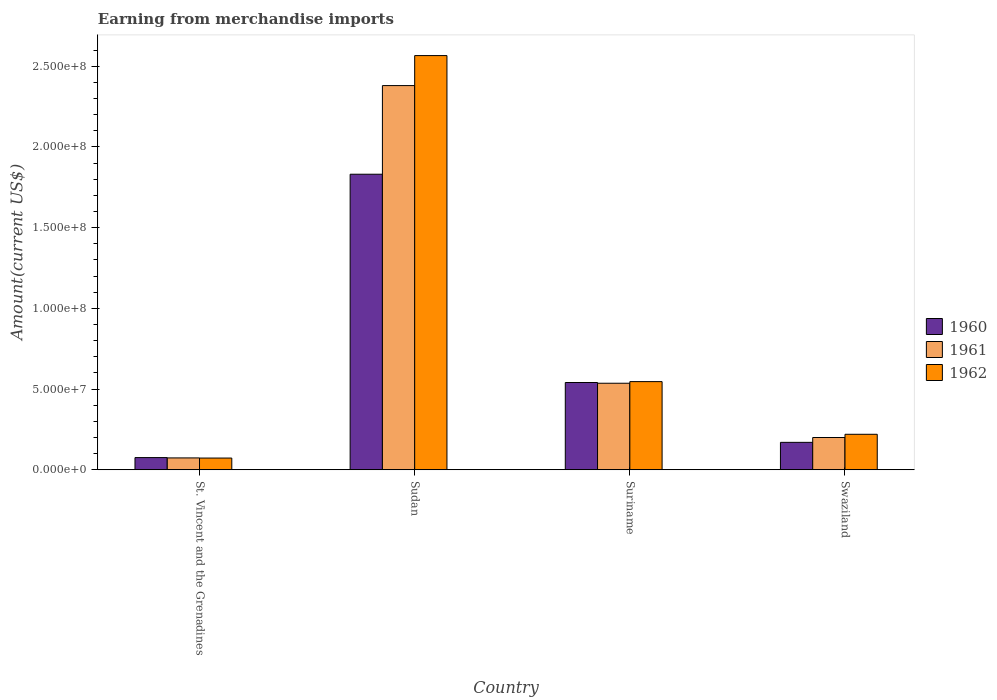Are the number of bars per tick equal to the number of legend labels?
Make the answer very short. Yes. How many bars are there on the 3rd tick from the right?
Provide a short and direct response. 3. What is the label of the 2nd group of bars from the left?
Make the answer very short. Sudan. What is the amount earned from merchandise imports in 1962 in Suriname?
Make the answer very short. 5.46e+07. Across all countries, what is the maximum amount earned from merchandise imports in 1960?
Provide a short and direct response. 1.83e+08. Across all countries, what is the minimum amount earned from merchandise imports in 1960?
Your answer should be compact. 7.57e+06. In which country was the amount earned from merchandise imports in 1960 maximum?
Offer a terse response. Sudan. In which country was the amount earned from merchandise imports in 1960 minimum?
Your answer should be very brief. St. Vincent and the Grenadines. What is the total amount earned from merchandise imports in 1961 in the graph?
Give a very brief answer. 3.19e+08. What is the difference between the amount earned from merchandise imports in 1960 in St. Vincent and the Grenadines and that in Swaziland?
Your response must be concise. -9.43e+06. What is the difference between the amount earned from merchandise imports in 1961 in Suriname and the amount earned from merchandise imports in 1962 in St. Vincent and the Grenadines?
Keep it short and to the point. 4.63e+07. What is the average amount earned from merchandise imports in 1961 per country?
Keep it short and to the point. 7.97e+07. In how many countries, is the amount earned from merchandise imports in 1961 greater than 170000000 US$?
Give a very brief answer. 1. What is the ratio of the amount earned from merchandise imports in 1961 in St. Vincent and the Grenadines to that in Swaziland?
Ensure brevity in your answer.  0.37. Is the amount earned from merchandise imports in 1962 in Suriname less than that in Swaziland?
Your response must be concise. No. What is the difference between the highest and the second highest amount earned from merchandise imports in 1960?
Provide a short and direct response. 1.66e+08. What is the difference between the highest and the lowest amount earned from merchandise imports in 1962?
Offer a terse response. 2.49e+08. What does the 1st bar from the left in St. Vincent and the Grenadines represents?
Your answer should be compact. 1960. What does the 1st bar from the right in Swaziland represents?
Provide a short and direct response. 1962. Is it the case that in every country, the sum of the amount earned from merchandise imports in 1962 and amount earned from merchandise imports in 1961 is greater than the amount earned from merchandise imports in 1960?
Give a very brief answer. Yes. Are all the bars in the graph horizontal?
Make the answer very short. No. Are the values on the major ticks of Y-axis written in scientific E-notation?
Ensure brevity in your answer.  Yes. Does the graph contain any zero values?
Make the answer very short. No. How are the legend labels stacked?
Keep it short and to the point. Vertical. What is the title of the graph?
Make the answer very short. Earning from merchandise imports. Does "1990" appear as one of the legend labels in the graph?
Your answer should be compact. No. What is the label or title of the Y-axis?
Ensure brevity in your answer.  Amount(current US$). What is the Amount(current US$) in 1960 in St. Vincent and the Grenadines?
Offer a very short reply. 7.57e+06. What is the Amount(current US$) in 1961 in St. Vincent and the Grenadines?
Make the answer very short. 7.37e+06. What is the Amount(current US$) in 1962 in St. Vincent and the Grenadines?
Your answer should be compact. 7.28e+06. What is the Amount(current US$) in 1960 in Sudan?
Ensure brevity in your answer.  1.83e+08. What is the Amount(current US$) of 1961 in Sudan?
Keep it short and to the point. 2.38e+08. What is the Amount(current US$) of 1962 in Sudan?
Offer a very short reply. 2.57e+08. What is the Amount(current US$) in 1960 in Suriname?
Your response must be concise. 5.41e+07. What is the Amount(current US$) of 1961 in Suriname?
Make the answer very short. 5.36e+07. What is the Amount(current US$) in 1962 in Suriname?
Provide a short and direct response. 5.46e+07. What is the Amount(current US$) of 1960 in Swaziland?
Make the answer very short. 1.70e+07. What is the Amount(current US$) in 1961 in Swaziland?
Your answer should be very brief. 2.00e+07. What is the Amount(current US$) in 1962 in Swaziland?
Ensure brevity in your answer.  2.20e+07. Across all countries, what is the maximum Amount(current US$) of 1960?
Provide a succinct answer. 1.83e+08. Across all countries, what is the maximum Amount(current US$) of 1961?
Make the answer very short. 2.38e+08. Across all countries, what is the maximum Amount(current US$) of 1962?
Make the answer very short. 2.57e+08. Across all countries, what is the minimum Amount(current US$) of 1960?
Your answer should be compact. 7.57e+06. Across all countries, what is the minimum Amount(current US$) of 1961?
Make the answer very short. 7.37e+06. Across all countries, what is the minimum Amount(current US$) in 1962?
Keep it short and to the point. 7.28e+06. What is the total Amount(current US$) of 1960 in the graph?
Offer a terse response. 2.62e+08. What is the total Amount(current US$) of 1961 in the graph?
Make the answer very short. 3.19e+08. What is the total Amount(current US$) in 1962 in the graph?
Your response must be concise. 3.40e+08. What is the difference between the Amount(current US$) in 1960 in St. Vincent and the Grenadines and that in Sudan?
Your answer should be very brief. -1.75e+08. What is the difference between the Amount(current US$) of 1961 in St. Vincent and the Grenadines and that in Sudan?
Your response must be concise. -2.31e+08. What is the difference between the Amount(current US$) in 1962 in St. Vincent and the Grenadines and that in Sudan?
Ensure brevity in your answer.  -2.49e+08. What is the difference between the Amount(current US$) in 1960 in St. Vincent and the Grenadines and that in Suriname?
Your answer should be compact. -4.65e+07. What is the difference between the Amount(current US$) in 1961 in St. Vincent and the Grenadines and that in Suriname?
Provide a succinct answer. -4.62e+07. What is the difference between the Amount(current US$) of 1962 in St. Vincent and the Grenadines and that in Suriname?
Your response must be concise. -4.73e+07. What is the difference between the Amount(current US$) of 1960 in St. Vincent and the Grenadines and that in Swaziland?
Offer a terse response. -9.43e+06. What is the difference between the Amount(current US$) in 1961 in St. Vincent and the Grenadines and that in Swaziland?
Make the answer very short. -1.26e+07. What is the difference between the Amount(current US$) in 1962 in St. Vincent and the Grenadines and that in Swaziland?
Ensure brevity in your answer.  -1.47e+07. What is the difference between the Amount(current US$) of 1960 in Sudan and that in Suriname?
Provide a short and direct response. 1.29e+08. What is the difference between the Amount(current US$) in 1961 in Sudan and that in Suriname?
Ensure brevity in your answer.  1.84e+08. What is the difference between the Amount(current US$) of 1962 in Sudan and that in Suriname?
Offer a very short reply. 2.02e+08. What is the difference between the Amount(current US$) of 1960 in Sudan and that in Swaziland?
Provide a short and direct response. 1.66e+08. What is the difference between the Amount(current US$) in 1961 in Sudan and that in Swaziland?
Make the answer very short. 2.18e+08. What is the difference between the Amount(current US$) in 1962 in Sudan and that in Swaziland?
Your answer should be compact. 2.35e+08. What is the difference between the Amount(current US$) in 1960 in Suriname and that in Swaziland?
Provide a short and direct response. 3.71e+07. What is the difference between the Amount(current US$) in 1961 in Suriname and that in Swaziland?
Provide a short and direct response. 3.36e+07. What is the difference between the Amount(current US$) in 1962 in Suriname and that in Swaziland?
Ensure brevity in your answer.  3.26e+07. What is the difference between the Amount(current US$) of 1960 in St. Vincent and the Grenadines and the Amount(current US$) of 1961 in Sudan?
Offer a very short reply. -2.30e+08. What is the difference between the Amount(current US$) of 1960 in St. Vincent and the Grenadines and the Amount(current US$) of 1962 in Sudan?
Your answer should be compact. -2.49e+08. What is the difference between the Amount(current US$) in 1961 in St. Vincent and the Grenadines and the Amount(current US$) in 1962 in Sudan?
Keep it short and to the point. -2.49e+08. What is the difference between the Amount(current US$) of 1960 in St. Vincent and the Grenadines and the Amount(current US$) of 1961 in Suriname?
Keep it short and to the point. -4.60e+07. What is the difference between the Amount(current US$) of 1960 in St. Vincent and the Grenadines and the Amount(current US$) of 1962 in Suriname?
Your answer should be very brief. -4.70e+07. What is the difference between the Amount(current US$) in 1961 in St. Vincent and the Grenadines and the Amount(current US$) in 1962 in Suriname?
Your answer should be compact. -4.72e+07. What is the difference between the Amount(current US$) in 1960 in St. Vincent and the Grenadines and the Amount(current US$) in 1961 in Swaziland?
Offer a terse response. -1.24e+07. What is the difference between the Amount(current US$) of 1960 in St. Vincent and the Grenadines and the Amount(current US$) of 1962 in Swaziland?
Offer a very short reply. -1.44e+07. What is the difference between the Amount(current US$) of 1961 in St. Vincent and the Grenadines and the Amount(current US$) of 1962 in Swaziland?
Your answer should be compact. -1.46e+07. What is the difference between the Amount(current US$) in 1960 in Sudan and the Amount(current US$) in 1961 in Suriname?
Make the answer very short. 1.29e+08. What is the difference between the Amount(current US$) in 1960 in Sudan and the Amount(current US$) in 1962 in Suriname?
Ensure brevity in your answer.  1.28e+08. What is the difference between the Amount(current US$) of 1961 in Sudan and the Amount(current US$) of 1962 in Suriname?
Your response must be concise. 1.83e+08. What is the difference between the Amount(current US$) in 1960 in Sudan and the Amount(current US$) in 1961 in Swaziland?
Your answer should be compact. 1.63e+08. What is the difference between the Amount(current US$) in 1960 in Sudan and the Amount(current US$) in 1962 in Swaziland?
Keep it short and to the point. 1.61e+08. What is the difference between the Amount(current US$) in 1961 in Sudan and the Amount(current US$) in 1962 in Swaziland?
Offer a terse response. 2.16e+08. What is the difference between the Amount(current US$) in 1960 in Suriname and the Amount(current US$) in 1961 in Swaziland?
Provide a short and direct response. 3.41e+07. What is the difference between the Amount(current US$) of 1960 in Suriname and the Amount(current US$) of 1962 in Swaziland?
Your answer should be very brief. 3.21e+07. What is the difference between the Amount(current US$) of 1961 in Suriname and the Amount(current US$) of 1962 in Swaziland?
Your response must be concise. 3.16e+07. What is the average Amount(current US$) in 1960 per country?
Give a very brief answer. 6.54e+07. What is the average Amount(current US$) of 1961 per country?
Make the answer very short. 7.97e+07. What is the average Amount(current US$) in 1962 per country?
Your answer should be compact. 8.51e+07. What is the difference between the Amount(current US$) of 1960 and Amount(current US$) of 1961 in St. Vincent and the Grenadines?
Keep it short and to the point. 2.00e+05. What is the difference between the Amount(current US$) in 1960 and Amount(current US$) in 1962 in St. Vincent and the Grenadines?
Give a very brief answer. 2.89e+05. What is the difference between the Amount(current US$) in 1961 and Amount(current US$) in 1962 in St. Vincent and the Grenadines?
Offer a terse response. 8.98e+04. What is the difference between the Amount(current US$) of 1960 and Amount(current US$) of 1961 in Sudan?
Ensure brevity in your answer.  -5.49e+07. What is the difference between the Amount(current US$) of 1960 and Amount(current US$) of 1962 in Sudan?
Give a very brief answer. -7.35e+07. What is the difference between the Amount(current US$) in 1961 and Amount(current US$) in 1962 in Sudan?
Your answer should be very brief. -1.86e+07. What is the difference between the Amount(current US$) of 1960 and Amount(current US$) of 1961 in Suriname?
Offer a terse response. 4.56e+05. What is the difference between the Amount(current US$) in 1960 and Amount(current US$) in 1962 in Suriname?
Provide a short and direct response. -5.52e+05. What is the difference between the Amount(current US$) of 1961 and Amount(current US$) of 1962 in Suriname?
Offer a very short reply. -1.01e+06. What is the difference between the Amount(current US$) of 1960 and Amount(current US$) of 1961 in Swaziland?
Keep it short and to the point. -3.00e+06. What is the difference between the Amount(current US$) of 1960 and Amount(current US$) of 1962 in Swaziland?
Provide a succinct answer. -5.00e+06. What is the ratio of the Amount(current US$) of 1960 in St. Vincent and the Grenadines to that in Sudan?
Keep it short and to the point. 0.04. What is the ratio of the Amount(current US$) in 1961 in St. Vincent and the Grenadines to that in Sudan?
Offer a very short reply. 0.03. What is the ratio of the Amount(current US$) of 1962 in St. Vincent and the Grenadines to that in Sudan?
Your answer should be compact. 0.03. What is the ratio of the Amount(current US$) in 1960 in St. Vincent and the Grenadines to that in Suriname?
Provide a succinct answer. 0.14. What is the ratio of the Amount(current US$) of 1961 in St. Vincent and the Grenadines to that in Suriname?
Offer a terse response. 0.14. What is the ratio of the Amount(current US$) of 1962 in St. Vincent and the Grenadines to that in Suriname?
Offer a very short reply. 0.13. What is the ratio of the Amount(current US$) in 1960 in St. Vincent and the Grenadines to that in Swaziland?
Give a very brief answer. 0.45. What is the ratio of the Amount(current US$) in 1961 in St. Vincent and the Grenadines to that in Swaziland?
Your answer should be compact. 0.37. What is the ratio of the Amount(current US$) of 1962 in St. Vincent and the Grenadines to that in Swaziland?
Offer a terse response. 0.33. What is the ratio of the Amount(current US$) of 1960 in Sudan to that in Suriname?
Keep it short and to the point. 3.39. What is the ratio of the Amount(current US$) of 1961 in Sudan to that in Suriname?
Give a very brief answer. 4.44. What is the ratio of the Amount(current US$) of 1962 in Sudan to that in Suriname?
Offer a terse response. 4.7. What is the ratio of the Amount(current US$) of 1960 in Sudan to that in Swaziland?
Keep it short and to the point. 10.77. What is the ratio of the Amount(current US$) of 1961 in Sudan to that in Swaziland?
Your response must be concise. 11.9. What is the ratio of the Amount(current US$) of 1962 in Sudan to that in Swaziland?
Your answer should be compact. 11.66. What is the ratio of the Amount(current US$) in 1960 in Suriname to that in Swaziland?
Provide a succinct answer. 3.18. What is the ratio of the Amount(current US$) of 1961 in Suriname to that in Swaziland?
Provide a short and direct response. 2.68. What is the ratio of the Amount(current US$) of 1962 in Suriname to that in Swaziland?
Ensure brevity in your answer.  2.48. What is the difference between the highest and the second highest Amount(current US$) in 1960?
Make the answer very short. 1.29e+08. What is the difference between the highest and the second highest Amount(current US$) in 1961?
Keep it short and to the point. 1.84e+08. What is the difference between the highest and the second highest Amount(current US$) of 1962?
Your answer should be compact. 2.02e+08. What is the difference between the highest and the lowest Amount(current US$) in 1960?
Your answer should be very brief. 1.75e+08. What is the difference between the highest and the lowest Amount(current US$) of 1961?
Provide a short and direct response. 2.31e+08. What is the difference between the highest and the lowest Amount(current US$) in 1962?
Ensure brevity in your answer.  2.49e+08. 